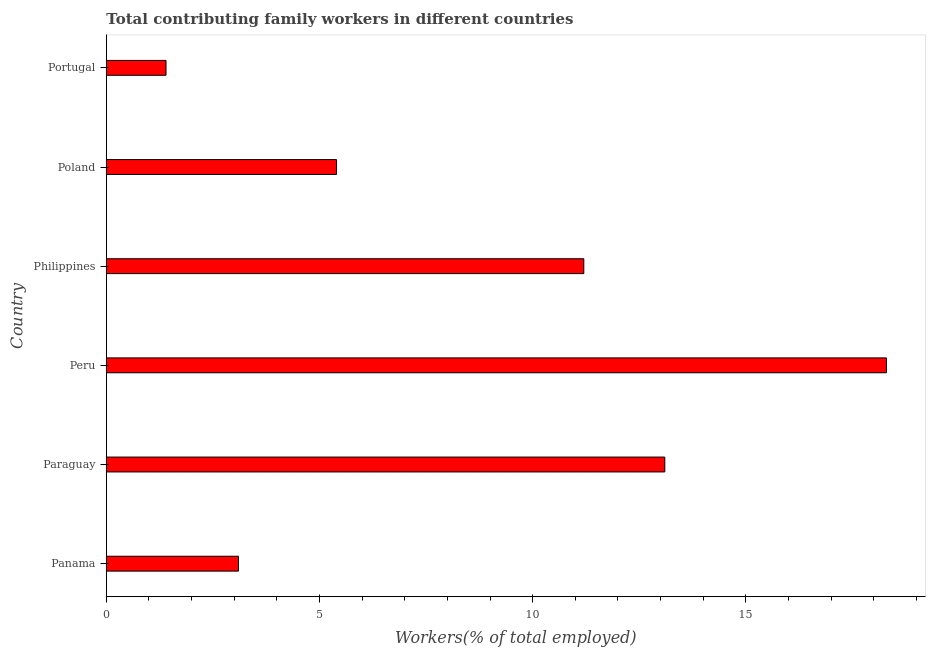Does the graph contain any zero values?
Provide a succinct answer. No. What is the title of the graph?
Offer a very short reply. Total contributing family workers in different countries. What is the label or title of the X-axis?
Make the answer very short. Workers(% of total employed). What is the label or title of the Y-axis?
Provide a short and direct response. Country. What is the contributing family workers in Portugal?
Provide a short and direct response. 1.4. Across all countries, what is the maximum contributing family workers?
Your answer should be very brief. 18.3. Across all countries, what is the minimum contributing family workers?
Offer a terse response. 1.4. In which country was the contributing family workers maximum?
Your response must be concise. Peru. What is the sum of the contributing family workers?
Keep it short and to the point. 52.5. What is the average contributing family workers per country?
Your answer should be compact. 8.75. What is the median contributing family workers?
Offer a very short reply. 8.3. In how many countries, is the contributing family workers greater than 17 %?
Your answer should be very brief. 1. What is the ratio of the contributing family workers in Poland to that in Portugal?
Your response must be concise. 3.86. Is the difference between the contributing family workers in Paraguay and Peru greater than the difference between any two countries?
Provide a short and direct response. No. Is the sum of the contributing family workers in Peru and Poland greater than the maximum contributing family workers across all countries?
Provide a short and direct response. Yes. How many countries are there in the graph?
Ensure brevity in your answer.  6. What is the difference between two consecutive major ticks on the X-axis?
Offer a terse response. 5. What is the Workers(% of total employed) of Panama?
Keep it short and to the point. 3.1. What is the Workers(% of total employed) of Paraguay?
Ensure brevity in your answer.  13.1. What is the Workers(% of total employed) of Peru?
Keep it short and to the point. 18.3. What is the Workers(% of total employed) in Philippines?
Your response must be concise. 11.2. What is the Workers(% of total employed) in Poland?
Offer a terse response. 5.4. What is the Workers(% of total employed) in Portugal?
Ensure brevity in your answer.  1.4. What is the difference between the Workers(% of total employed) in Panama and Paraguay?
Keep it short and to the point. -10. What is the difference between the Workers(% of total employed) in Panama and Peru?
Provide a succinct answer. -15.2. What is the difference between the Workers(% of total employed) in Panama and Philippines?
Your answer should be very brief. -8.1. What is the difference between the Workers(% of total employed) in Panama and Poland?
Give a very brief answer. -2.3. What is the difference between the Workers(% of total employed) in Panama and Portugal?
Offer a very short reply. 1.7. What is the difference between the Workers(% of total employed) in Paraguay and Poland?
Make the answer very short. 7.7. What is the difference between the Workers(% of total employed) in Paraguay and Portugal?
Ensure brevity in your answer.  11.7. What is the difference between the Workers(% of total employed) in Peru and Poland?
Make the answer very short. 12.9. What is the difference between the Workers(% of total employed) in Philippines and Portugal?
Your answer should be compact. 9.8. What is the difference between the Workers(% of total employed) in Poland and Portugal?
Give a very brief answer. 4. What is the ratio of the Workers(% of total employed) in Panama to that in Paraguay?
Ensure brevity in your answer.  0.24. What is the ratio of the Workers(% of total employed) in Panama to that in Peru?
Your response must be concise. 0.17. What is the ratio of the Workers(% of total employed) in Panama to that in Philippines?
Keep it short and to the point. 0.28. What is the ratio of the Workers(% of total employed) in Panama to that in Poland?
Make the answer very short. 0.57. What is the ratio of the Workers(% of total employed) in Panama to that in Portugal?
Ensure brevity in your answer.  2.21. What is the ratio of the Workers(% of total employed) in Paraguay to that in Peru?
Offer a very short reply. 0.72. What is the ratio of the Workers(% of total employed) in Paraguay to that in Philippines?
Make the answer very short. 1.17. What is the ratio of the Workers(% of total employed) in Paraguay to that in Poland?
Provide a succinct answer. 2.43. What is the ratio of the Workers(% of total employed) in Paraguay to that in Portugal?
Your response must be concise. 9.36. What is the ratio of the Workers(% of total employed) in Peru to that in Philippines?
Offer a very short reply. 1.63. What is the ratio of the Workers(% of total employed) in Peru to that in Poland?
Your answer should be compact. 3.39. What is the ratio of the Workers(% of total employed) in Peru to that in Portugal?
Offer a very short reply. 13.07. What is the ratio of the Workers(% of total employed) in Philippines to that in Poland?
Give a very brief answer. 2.07. What is the ratio of the Workers(% of total employed) in Philippines to that in Portugal?
Your answer should be compact. 8. What is the ratio of the Workers(% of total employed) in Poland to that in Portugal?
Provide a succinct answer. 3.86. 